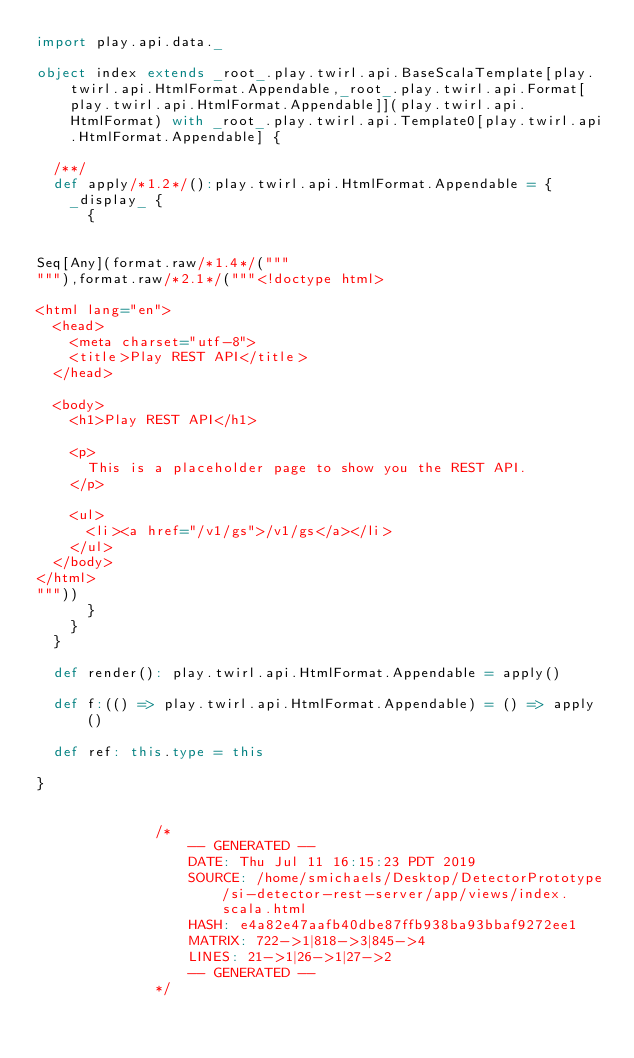<code> <loc_0><loc_0><loc_500><loc_500><_Scala_>import play.api.data._

object index extends _root_.play.twirl.api.BaseScalaTemplate[play.twirl.api.HtmlFormat.Appendable,_root_.play.twirl.api.Format[play.twirl.api.HtmlFormat.Appendable]](play.twirl.api.HtmlFormat) with _root_.play.twirl.api.Template0[play.twirl.api.HtmlFormat.Appendable] {

  /**/
  def apply/*1.2*/():play.twirl.api.HtmlFormat.Appendable = {
    _display_ {
      {


Seq[Any](format.raw/*1.4*/("""
"""),format.raw/*2.1*/("""<!doctype html>

<html lang="en">
  <head>
    <meta charset="utf-8">
    <title>Play REST API</title>
  </head>

  <body>
    <h1>Play REST API</h1>

    <p>
      This is a placeholder page to show you the REST API.
    </p>

    <ul>
      <li><a href="/v1/gs">/v1/gs</a></li>
    </ul>
  </body>
</html>
"""))
      }
    }
  }

  def render(): play.twirl.api.HtmlFormat.Appendable = apply()

  def f:(() => play.twirl.api.HtmlFormat.Appendable) = () => apply()

  def ref: this.type = this

}


              /*
                  -- GENERATED --
                  DATE: Thu Jul 11 16:15:23 PDT 2019
                  SOURCE: /home/smichaels/Desktop/DetectorPrototype/si-detector-rest-server/app/views/index.scala.html
                  HASH: e4a82e47aafb40dbe87ffb938ba93bbaf9272ee1
                  MATRIX: 722->1|818->3|845->4
                  LINES: 21->1|26->1|27->2
                  -- GENERATED --
              */
          </code> 